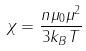<formula> <loc_0><loc_0><loc_500><loc_500>\chi = \frac { n \mu _ { 0 } \mu ^ { 2 } } { 3 k _ { B } T }</formula> 